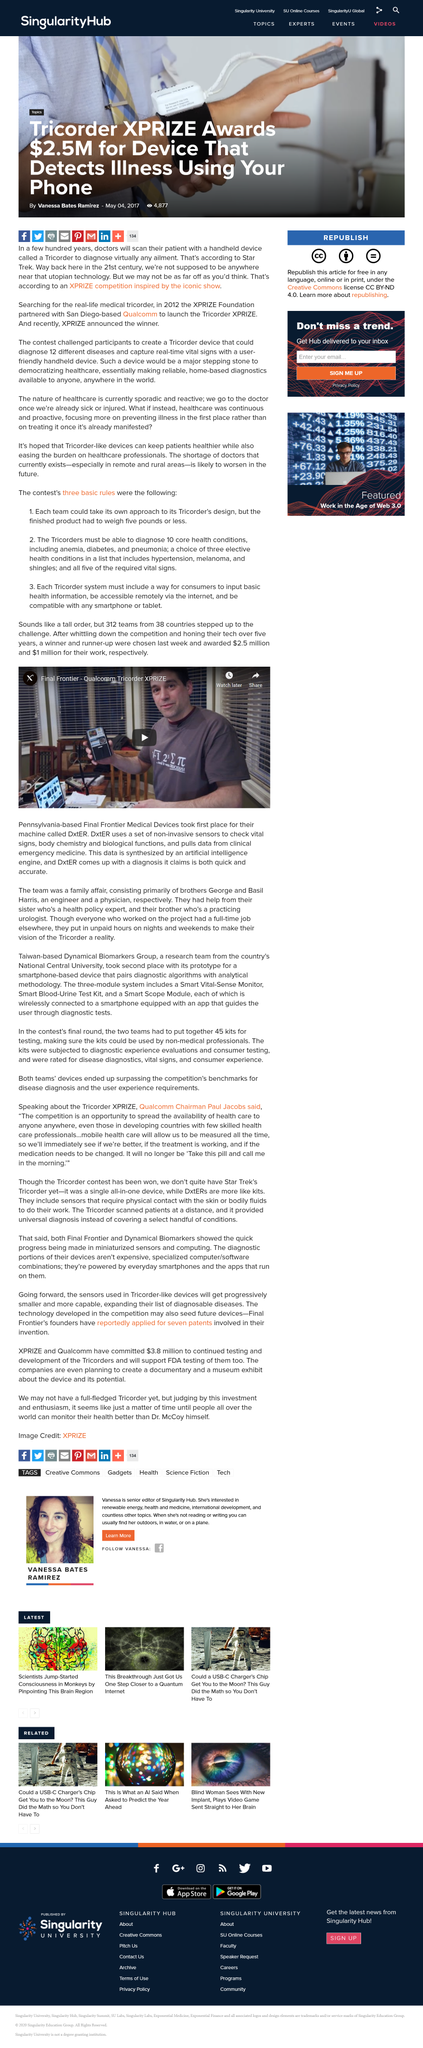List a handful of essential elements in this visual. The device described, which weighs 4 pounds, is capable of diagnosing all health conditions listed in rule 2, and is compatible only with Apple devices, would not be eligible based on the rules. The teams competing had a five-year timeframe to design a Tricorder that weighed less than five pounds. The total prize money awarded in this competition was $3.5 million. 